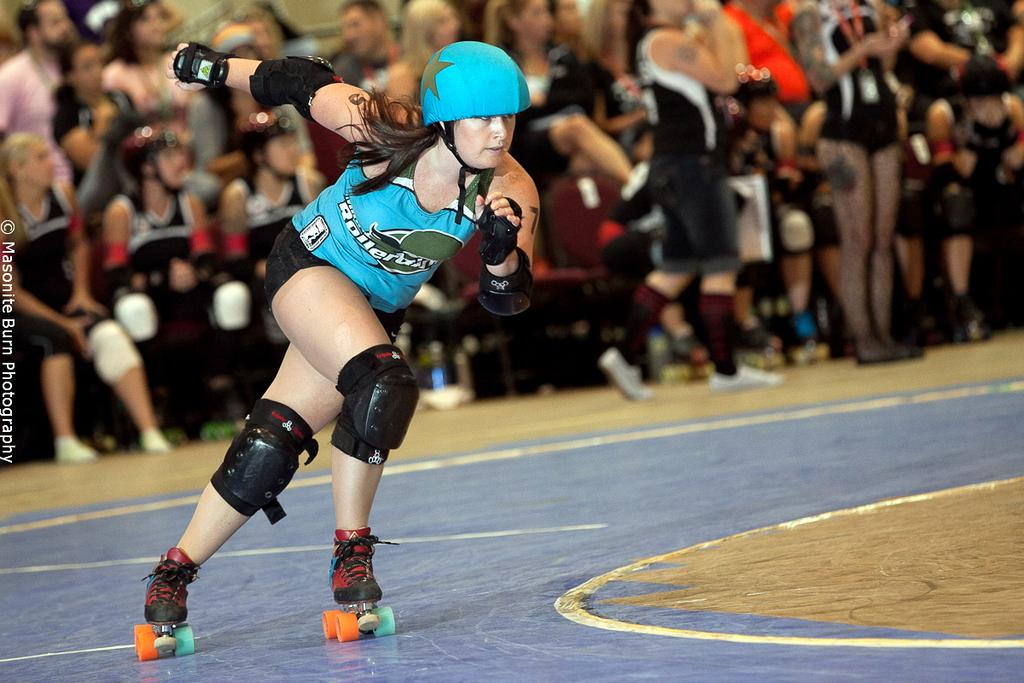What activity is the person in the foreground of the image engaged in? There is a person skating on the floor in the image. What can be seen in the background of the image? There are people sitting on chairs and people standing on the floor in the background. What type of bottle is being used by the governor in the image? There is no governor or bottle present in the image. 